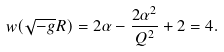<formula> <loc_0><loc_0><loc_500><loc_500>w ( \sqrt { - g } R ) = 2 \alpha - { \frac { 2 \alpha ^ { 2 } } { Q ^ { 2 } } } + 2 = 4 .</formula> 